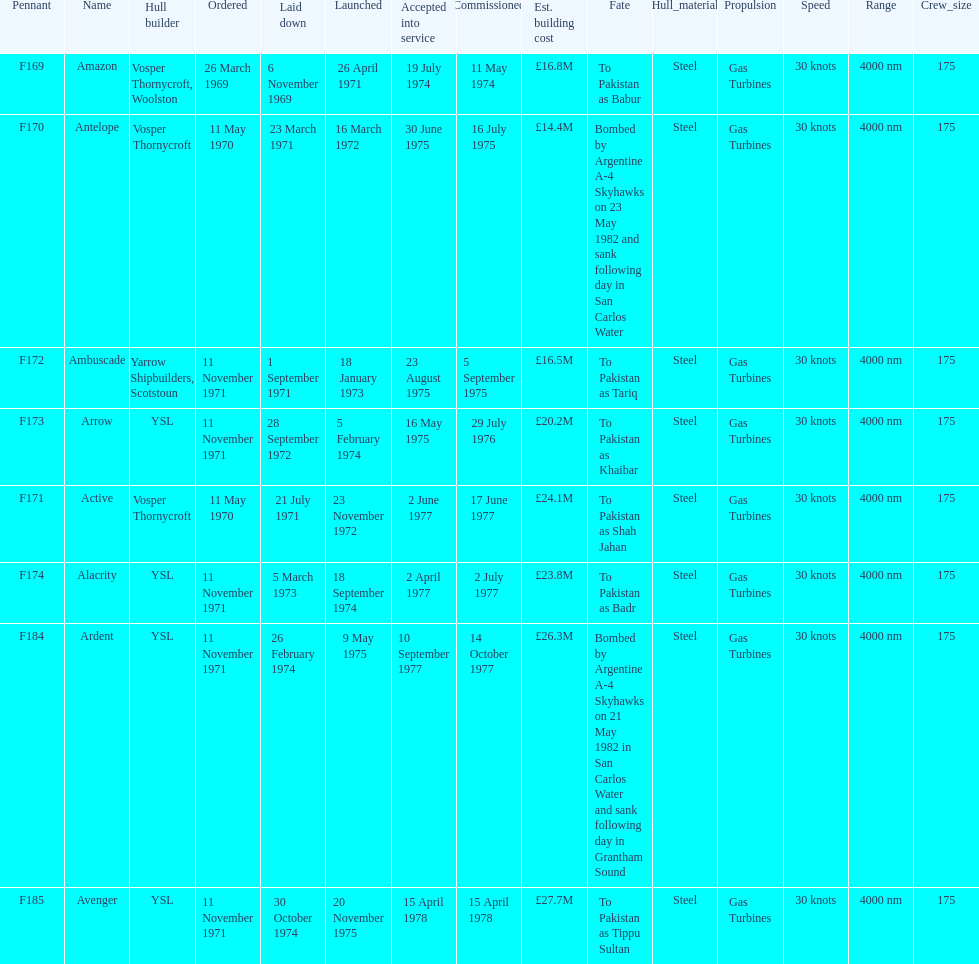Which ships cost more than ps25.0m to build? Ardent, Avenger. Of the ships listed in the answer above, which one cost the most to build? Avenger. 